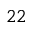<formula> <loc_0><loc_0><loc_500><loc_500>^ { 2 2 }</formula> 